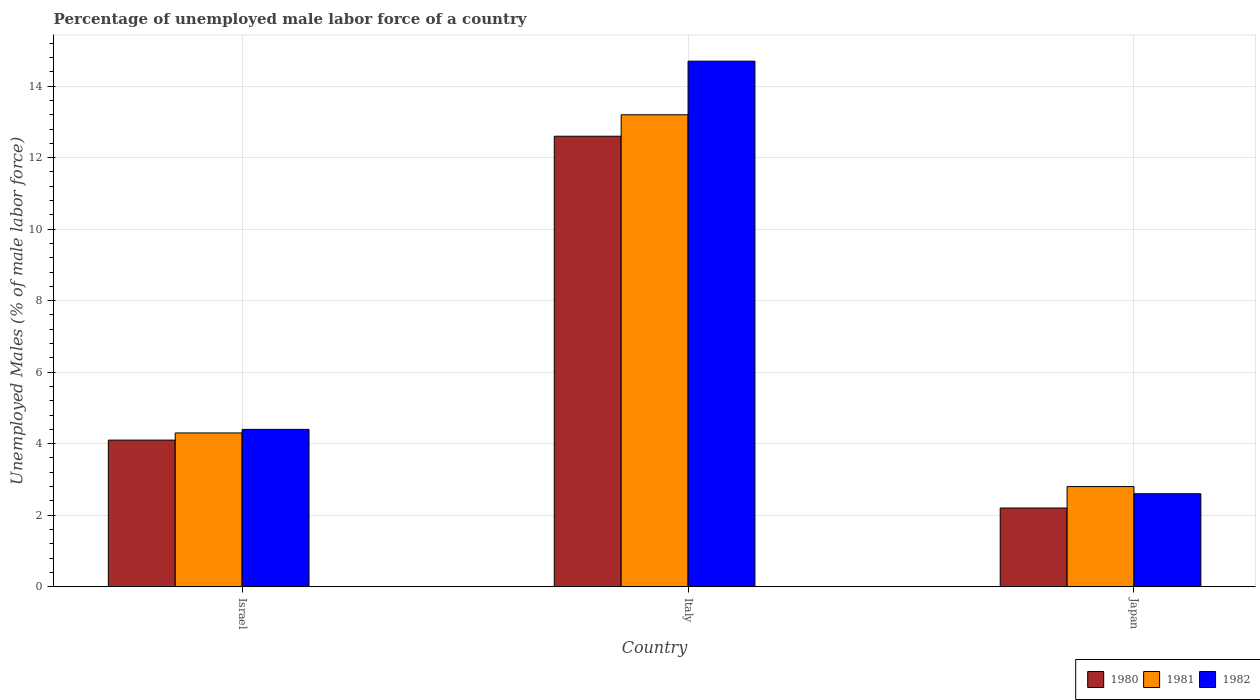How many groups of bars are there?
Offer a very short reply. 3. How many bars are there on the 2nd tick from the left?
Your answer should be compact. 3. What is the label of the 2nd group of bars from the left?
Offer a very short reply. Italy. What is the percentage of unemployed male labor force in 1982 in Italy?
Provide a short and direct response. 14.7. Across all countries, what is the maximum percentage of unemployed male labor force in 1981?
Offer a terse response. 13.2. Across all countries, what is the minimum percentage of unemployed male labor force in 1980?
Offer a very short reply. 2.2. In which country was the percentage of unemployed male labor force in 1981 maximum?
Your response must be concise. Italy. In which country was the percentage of unemployed male labor force in 1980 minimum?
Keep it short and to the point. Japan. What is the total percentage of unemployed male labor force in 1982 in the graph?
Ensure brevity in your answer.  21.7. What is the difference between the percentage of unemployed male labor force in 1981 in Israel and that in Italy?
Keep it short and to the point. -8.9. What is the difference between the percentage of unemployed male labor force in 1981 in Israel and the percentage of unemployed male labor force in 1982 in Japan?
Give a very brief answer. 1.7. What is the average percentage of unemployed male labor force in 1982 per country?
Your response must be concise. 7.23. What is the difference between the percentage of unemployed male labor force of/in 1980 and percentage of unemployed male labor force of/in 1982 in Italy?
Your answer should be very brief. -2.1. In how many countries, is the percentage of unemployed male labor force in 1981 greater than 2.8 %?
Your answer should be compact. 2. What is the ratio of the percentage of unemployed male labor force in 1981 in Israel to that in Japan?
Provide a succinct answer. 1.54. Is the percentage of unemployed male labor force in 1982 in Israel less than that in Italy?
Make the answer very short. Yes. What is the difference between the highest and the second highest percentage of unemployed male labor force in 1980?
Offer a very short reply. -10.4. What is the difference between the highest and the lowest percentage of unemployed male labor force in 1982?
Your answer should be compact. 12.1. Is the sum of the percentage of unemployed male labor force in 1982 in Israel and Japan greater than the maximum percentage of unemployed male labor force in 1981 across all countries?
Provide a short and direct response. No. What does the 3rd bar from the right in Italy represents?
Offer a terse response. 1980. How many bars are there?
Offer a very short reply. 9. Are all the bars in the graph horizontal?
Ensure brevity in your answer.  No. What is the difference between two consecutive major ticks on the Y-axis?
Your answer should be compact. 2. Does the graph contain any zero values?
Provide a succinct answer. No. Where does the legend appear in the graph?
Your answer should be very brief. Bottom right. How are the legend labels stacked?
Keep it short and to the point. Horizontal. What is the title of the graph?
Offer a terse response. Percentage of unemployed male labor force of a country. Does "1985" appear as one of the legend labels in the graph?
Ensure brevity in your answer.  No. What is the label or title of the Y-axis?
Your answer should be compact. Unemployed Males (% of male labor force). What is the Unemployed Males (% of male labor force) of 1980 in Israel?
Your answer should be very brief. 4.1. What is the Unemployed Males (% of male labor force) in 1981 in Israel?
Your answer should be very brief. 4.3. What is the Unemployed Males (% of male labor force) of 1982 in Israel?
Offer a terse response. 4.4. What is the Unemployed Males (% of male labor force) in 1980 in Italy?
Make the answer very short. 12.6. What is the Unemployed Males (% of male labor force) in 1981 in Italy?
Provide a short and direct response. 13.2. What is the Unemployed Males (% of male labor force) in 1982 in Italy?
Offer a very short reply. 14.7. What is the Unemployed Males (% of male labor force) in 1980 in Japan?
Give a very brief answer. 2.2. What is the Unemployed Males (% of male labor force) in 1981 in Japan?
Provide a succinct answer. 2.8. What is the Unemployed Males (% of male labor force) in 1982 in Japan?
Your answer should be very brief. 2.6. Across all countries, what is the maximum Unemployed Males (% of male labor force) in 1980?
Make the answer very short. 12.6. Across all countries, what is the maximum Unemployed Males (% of male labor force) in 1981?
Keep it short and to the point. 13.2. Across all countries, what is the maximum Unemployed Males (% of male labor force) in 1982?
Provide a short and direct response. 14.7. Across all countries, what is the minimum Unemployed Males (% of male labor force) in 1980?
Provide a short and direct response. 2.2. Across all countries, what is the minimum Unemployed Males (% of male labor force) of 1981?
Provide a succinct answer. 2.8. Across all countries, what is the minimum Unemployed Males (% of male labor force) in 1982?
Offer a terse response. 2.6. What is the total Unemployed Males (% of male labor force) in 1980 in the graph?
Provide a succinct answer. 18.9. What is the total Unemployed Males (% of male labor force) in 1981 in the graph?
Make the answer very short. 20.3. What is the total Unemployed Males (% of male labor force) of 1982 in the graph?
Your response must be concise. 21.7. What is the difference between the Unemployed Males (% of male labor force) in 1981 in Israel and that in Italy?
Give a very brief answer. -8.9. What is the difference between the Unemployed Males (% of male labor force) of 1982 in Israel and that in Japan?
Provide a short and direct response. 1.8. What is the difference between the Unemployed Males (% of male labor force) of 1980 in Italy and that in Japan?
Provide a succinct answer. 10.4. What is the difference between the Unemployed Males (% of male labor force) of 1981 in Italy and that in Japan?
Offer a terse response. 10.4. What is the difference between the Unemployed Males (% of male labor force) in 1982 in Italy and that in Japan?
Your answer should be very brief. 12.1. What is the difference between the Unemployed Males (% of male labor force) of 1980 in Israel and the Unemployed Males (% of male labor force) of 1982 in Italy?
Make the answer very short. -10.6. What is the difference between the Unemployed Males (% of male labor force) of 1980 in Israel and the Unemployed Males (% of male labor force) of 1981 in Japan?
Ensure brevity in your answer.  1.3. What is the average Unemployed Males (% of male labor force) of 1980 per country?
Offer a very short reply. 6.3. What is the average Unemployed Males (% of male labor force) in 1981 per country?
Ensure brevity in your answer.  6.77. What is the average Unemployed Males (% of male labor force) in 1982 per country?
Offer a terse response. 7.23. What is the ratio of the Unemployed Males (% of male labor force) in 1980 in Israel to that in Italy?
Your answer should be very brief. 0.33. What is the ratio of the Unemployed Males (% of male labor force) of 1981 in Israel to that in Italy?
Provide a short and direct response. 0.33. What is the ratio of the Unemployed Males (% of male labor force) in 1982 in Israel to that in Italy?
Your answer should be very brief. 0.3. What is the ratio of the Unemployed Males (% of male labor force) of 1980 in Israel to that in Japan?
Provide a succinct answer. 1.86. What is the ratio of the Unemployed Males (% of male labor force) of 1981 in Israel to that in Japan?
Ensure brevity in your answer.  1.54. What is the ratio of the Unemployed Males (% of male labor force) in 1982 in Israel to that in Japan?
Provide a short and direct response. 1.69. What is the ratio of the Unemployed Males (% of male labor force) of 1980 in Italy to that in Japan?
Offer a terse response. 5.73. What is the ratio of the Unemployed Males (% of male labor force) in 1981 in Italy to that in Japan?
Give a very brief answer. 4.71. What is the ratio of the Unemployed Males (% of male labor force) of 1982 in Italy to that in Japan?
Ensure brevity in your answer.  5.65. What is the difference between the highest and the second highest Unemployed Males (% of male labor force) of 1982?
Provide a short and direct response. 10.3. What is the difference between the highest and the lowest Unemployed Males (% of male labor force) in 1980?
Make the answer very short. 10.4. What is the difference between the highest and the lowest Unemployed Males (% of male labor force) of 1981?
Your answer should be very brief. 10.4. 